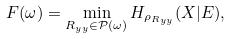<formula> <loc_0><loc_0><loc_500><loc_500>F ( \omega ) = \min _ { R _ { y y } \in \mathcal { P } ( \omega ) } H _ { \rho _ { R _ { y y } } } ( X | E ) ,</formula> 